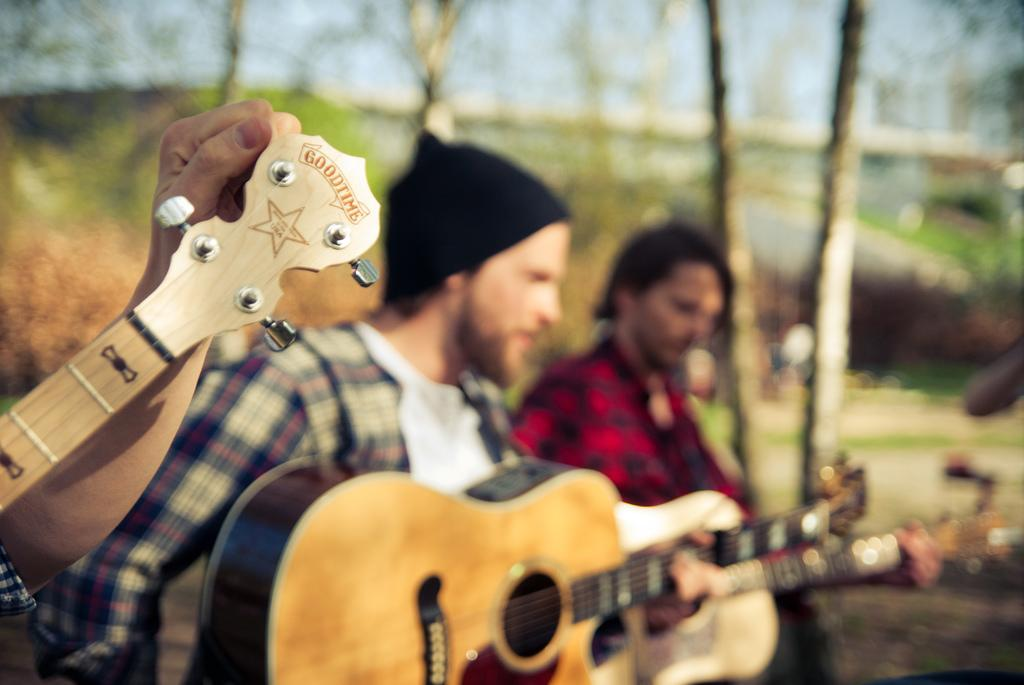How many people are in the image? There are three people in the image. What are the people doing in the image? The people are holding a guitar and playing it. What can be seen in the background of the image? There are trees and the sky visible in the background of the image. What type of beam is holding up the trees in the image? There is no beam present in the image; the trees are standing on their own. 